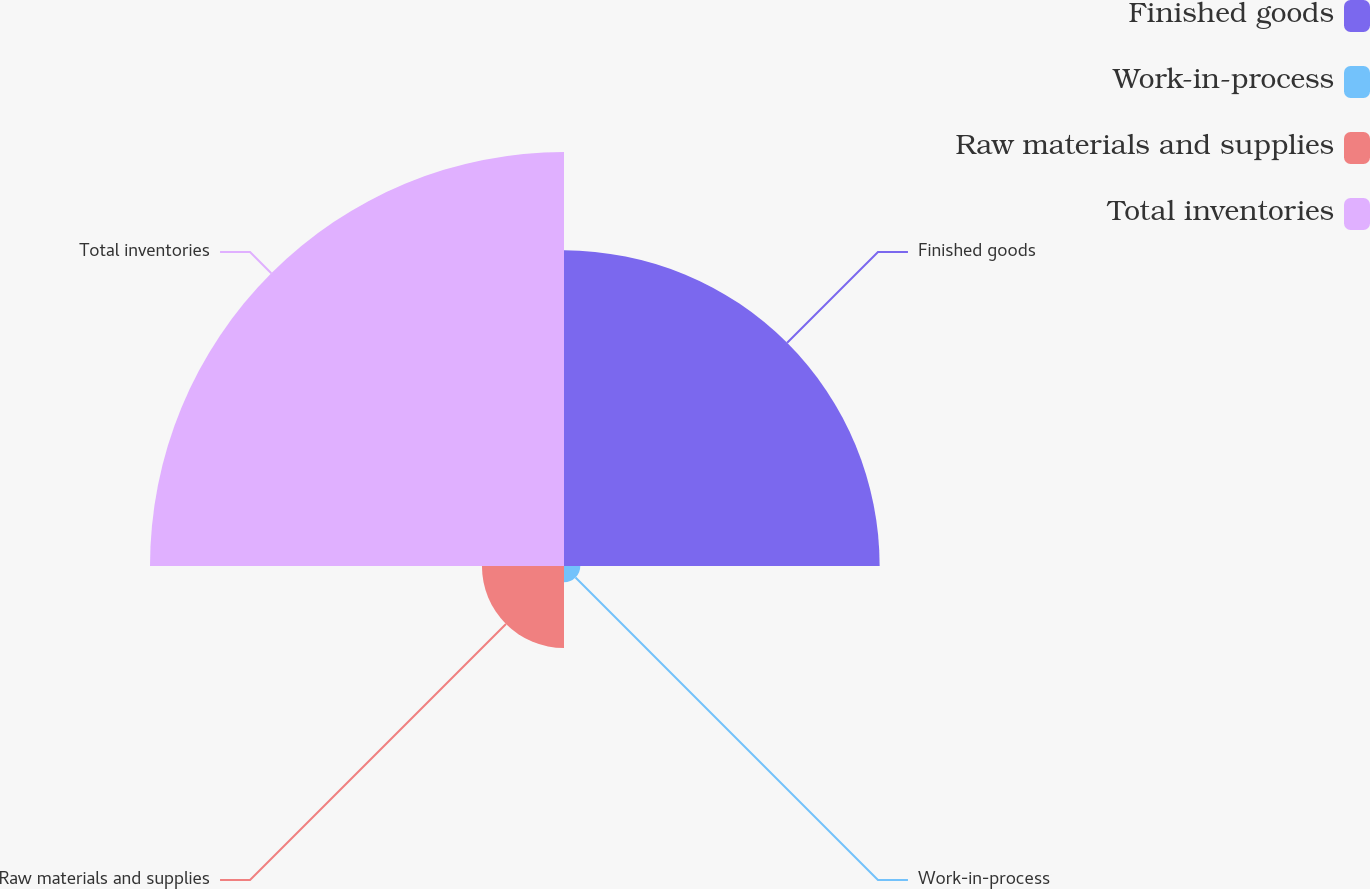Convert chart. <chart><loc_0><loc_0><loc_500><loc_500><pie_chart><fcel>Finished goods<fcel>Work-in-process<fcel>Raw materials and supplies<fcel>Total inventories<nl><fcel>38.12%<fcel>1.97%<fcel>9.91%<fcel>50.0%<nl></chart> 